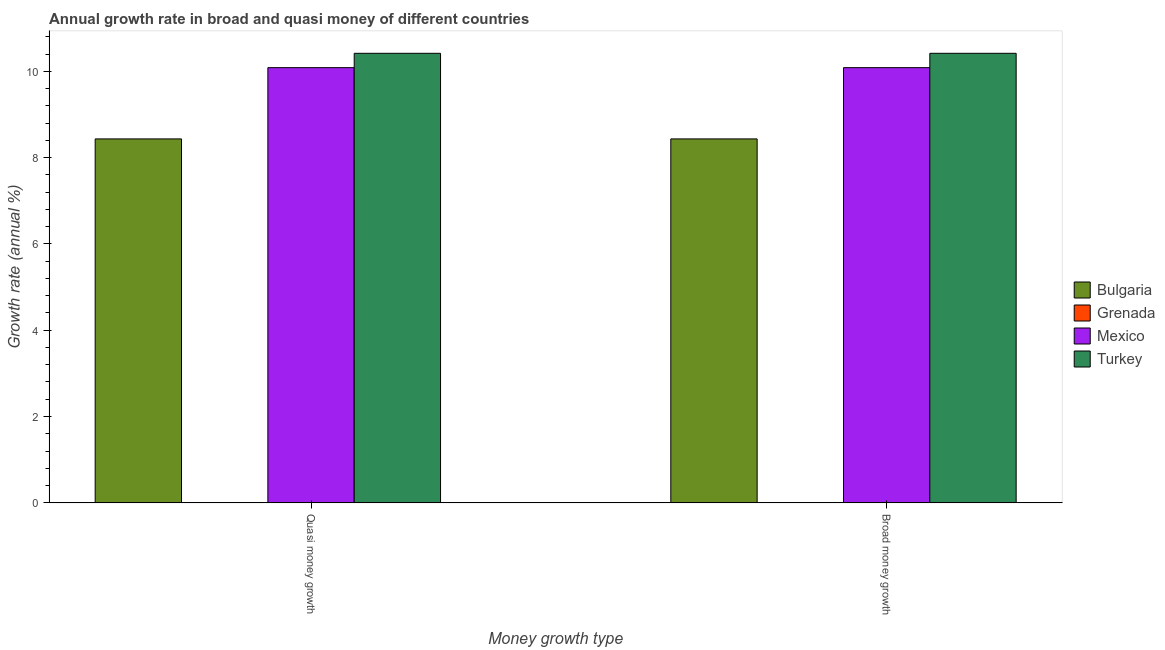How many different coloured bars are there?
Provide a succinct answer. 3. Are the number of bars per tick equal to the number of legend labels?
Your answer should be compact. No. Are the number of bars on each tick of the X-axis equal?
Ensure brevity in your answer.  Yes. How many bars are there on the 1st tick from the left?
Keep it short and to the point. 3. How many bars are there on the 2nd tick from the right?
Your response must be concise. 3. What is the label of the 2nd group of bars from the left?
Your answer should be very brief. Broad money growth. What is the annual growth rate in quasi money in Grenada?
Offer a very short reply. 0. Across all countries, what is the maximum annual growth rate in broad money?
Your response must be concise. 10.42. Across all countries, what is the minimum annual growth rate in quasi money?
Provide a succinct answer. 0. What is the total annual growth rate in broad money in the graph?
Provide a short and direct response. 28.93. What is the difference between the annual growth rate in broad money in Turkey and that in Bulgaria?
Your response must be concise. 1.98. What is the difference between the annual growth rate in quasi money in Grenada and the annual growth rate in broad money in Mexico?
Provide a succinct answer. -10.08. What is the average annual growth rate in quasi money per country?
Provide a short and direct response. 7.23. What is the difference between the annual growth rate in broad money and annual growth rate in quasi money in Turkey?
Offer a terse response. 0. In how many countries, is the annual growth rate in broad money greater than 5.2 %?
Provide a short and direct response. 3. What is the ratio of the annual growth rate in quasi money in Bulgaria to that in Mexico?
Ensure brevity in your answer.  0.84. In how many countries, is the annual growth rate in quasi money greater than the average annual growth rate in quasi money taken over all countries?
Provide a short and direct response. 3. Are all the bars in the graph horizontal?
Your answer should be compact. No. How many countries are there in the graph?
Give a very brief answer. 4. Are the values on the major ticks of Y-axis written in scientific E-notation?
Your answer should be very brief. No. Where does the legend appear in the graph?
Ensure brevity in your answer.  Center right. What is the title of the graph?
Your answer should be very brief. Annual growth rate in broad and quasi money of different countries. Does "Suriname" appear as one of the legend labels in the graph?
Offer a very short reply. No. What is the label or title of the X-axis?
Give a very brief answer. Money growth type. What is the label or title of the Y-axis?
Give a very brief answer. Growth rate (annual %). What is the Growth rate (annual %) in Bulgaria in Quasi money growth?
Keep it short and to the point. 8.43. What is the Growth rate (annual %) in Grenada in Quasi money growth?
Your answer should be very brief. 0. What is the Growth rate (annual %) in Mexico in Quasi money growth?
Your answer should be very brief. 10.08. What is the Growth rate (annual %) of Turkey in Quasi money growth?
Ensure brevity in your answer.  10.42. What is the Growth rate (annual %) in Bulgaria in Broad money growth?
Provide a short and direct response. 8.43. What is the Growth rate (annual %) in Grenada in Broad money growth?
Offer a terse response. 0. What is the Growth rate (annual %) of Mexico in Broad money growth?
Offer a terse response. 10.08. What is the Growth rate (annual %) in Turkey in Broad money growth?
Make the answer very short. 10.42. Across all Money growth type, what is the maximum Growth rate (annual %) in Bulgaria?
Your answer should be compact. 8.43. Across all Money growth type, what is the maximum Growth rate (annual %) of Mexico?
Your answer should be compact. 10.08. Across all Money growth type, what is the maximum Growth rate (annual %) in Turkey?
Offer a very short reply. 10.42. Across all Money growth type, what is the minimum Growth rate (annual %) in Bulgaria?
Keep it short and to the point. 8.43. Across all Money growth type, what is the minimum Growth rate (annual %) in Mexico?
Make the answer very short. 10.08. Across all Money growth type, what is the minimum Growth rate (annual %) of Turkey?
Provide a succinct answer. 10.42. What is the total Growth rate (annual %) of Bulgaria in the graph?
Provide a short and direct response. 16.86. What is the total Growth rate (annual %) of Mexico in the graph?
Provide a short and direct response. 20.17. What is the total Growth rate (annual %) of Turkey in the graph?
Keep it short and to the point. 20.83. What is the difference between the Growth rate (annual %) in Bulgaria in Quasi money growth and the Growth rate (annual %) in Mexico in Broad money growth?
Your answer should be very brief. -1.65. What is the difference between the Growth rate (annual %) of Bulgaria in Quasi money growth and the Growth rate (annual %) of Turkey in Broad money growth?
Your answer should be very brief. -1.98. What is the difference between the Growth rate (annual %) in Mexico in Quasi money growth and the Growth rate (annual %) in Turkey in Broad money growth?
Your answer should be very brief. -0.33. What is the average Growth rate (annual %) of Bulgaria per Money growth type?
Offer a terse response. 8.43. What is the average Growth rate (annual %) in Mexico per Money growth type?
Offer a very short reply. 10.08. What is the average Growth rate (annual %) in Turkey per Money growth type?
Offer a very short reply. 10.42. What is the difference between the Growth rate (annual %) in Bulgaria and Growth rate (annual %) in Mexico in Quasi money growth?
Offer a terse response. -1.65. What is the difference between the Growth rate (annual %) of Bulgaria and Growth rate (annual %) of Turkey in Quasi money growth?
Give a very brief answer. -1.98. What is the difference between the Growth rate (annual %) of Mexico and Growth rate (annual %) of Turkey in Quasi money growth?
Make the answer very short. -0.33. What is the difference between the Growth rate (annual %) in Bulgaria and Growth rate (annual %) in Mexico in Broad money growth?
Offer a terse response. -1.65. What is the difference between the Growth rate (annual %) of Bulgaria and Growth rate (annual %) of Turkey in Broad money growth?
Make the answer very short. -1.98. What is the difference between the Growth rate (annual %) of Mexico and Growth rate (annual %) of Turkey in Broad money growth?
Provide a succinct answer. -0.33. What is the difference between the highest and the second highest Growth rate (annual %) of Bulgaria?
Provide a short and direct response. 0. What is the difference between the highest and the second highest Growth rate (annual %) of Turkey?
Your answer should be compact. 0. What is the difference between the highest and the lowest Growth rate (annual %) of Bulgaria?
Your answer should be compact. 0. What is the difference between the highest and the lowest Growth rate (annual %) in Turkey?
Keep it short and to the point. 0. 